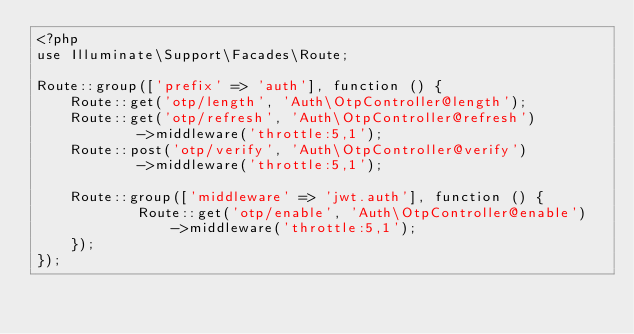Convert code to text. <code><loc_0><loc_0><loc_500><loc_500><_PHP_><?php
use Illuminate\Support\Facades\Route;

Route::group(['prefix' => 'auth'], function () {
    Route::get('otp/length', 'Auth\OtpController@length');
    Route::get('otp/refresh', 'Auth\OtpController@refresh')
            ->middleware('throttle:5,1');
    Route::post('otp/verify', 'Auth\OtpController@verify')
            ->middleware('throttle:5,1');

    Route::group(['middleware' => 'jwt.auth'], function () {
            Route::get('otp/enable', 'Auth\OtpController@enable')
                ->middleware('throttle:5,1');
    });
});
</code> 